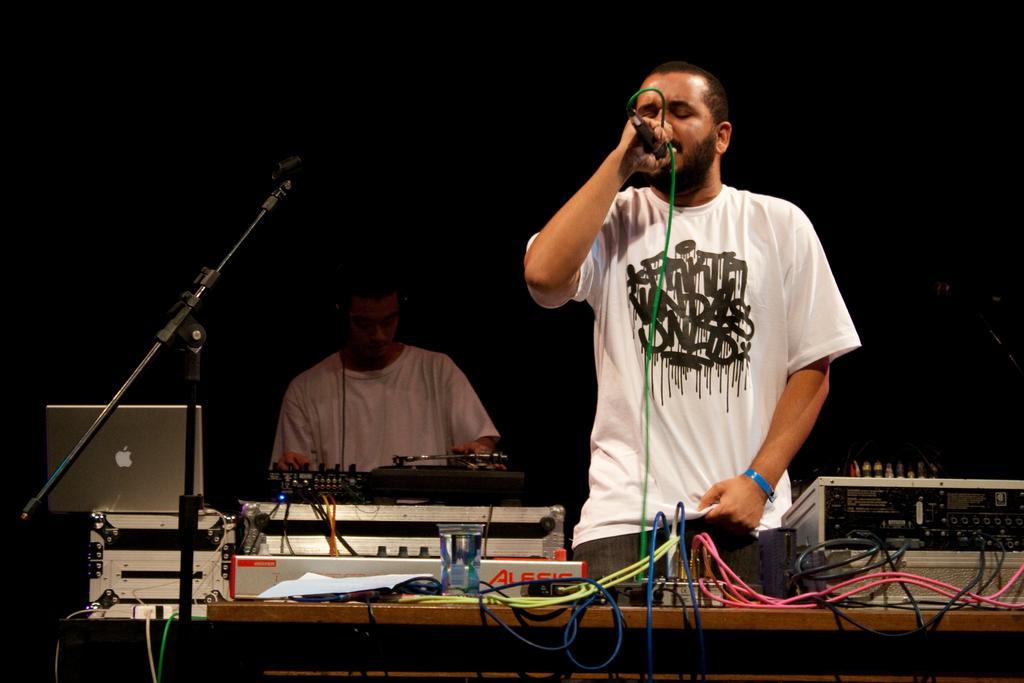In one or two sentences, can you explain what this image depicts? There is a man standing and holding microphone and we can see cables,electrical device and some objects on table. On the background there is a person and we can see microphone with stand and electrical devices. 